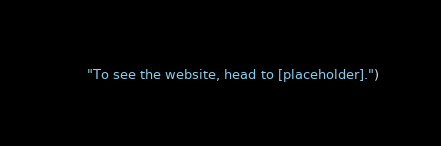<code> <loc_0><loc_0><loc_500><loc_500><_Python_>      "To see the website, head to [placeholder].")</code> 